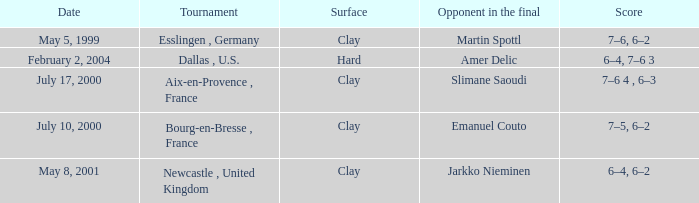What is the Score of the Tournament with Opponent in the final of Martin Spottl? 7–6, 6–2. 